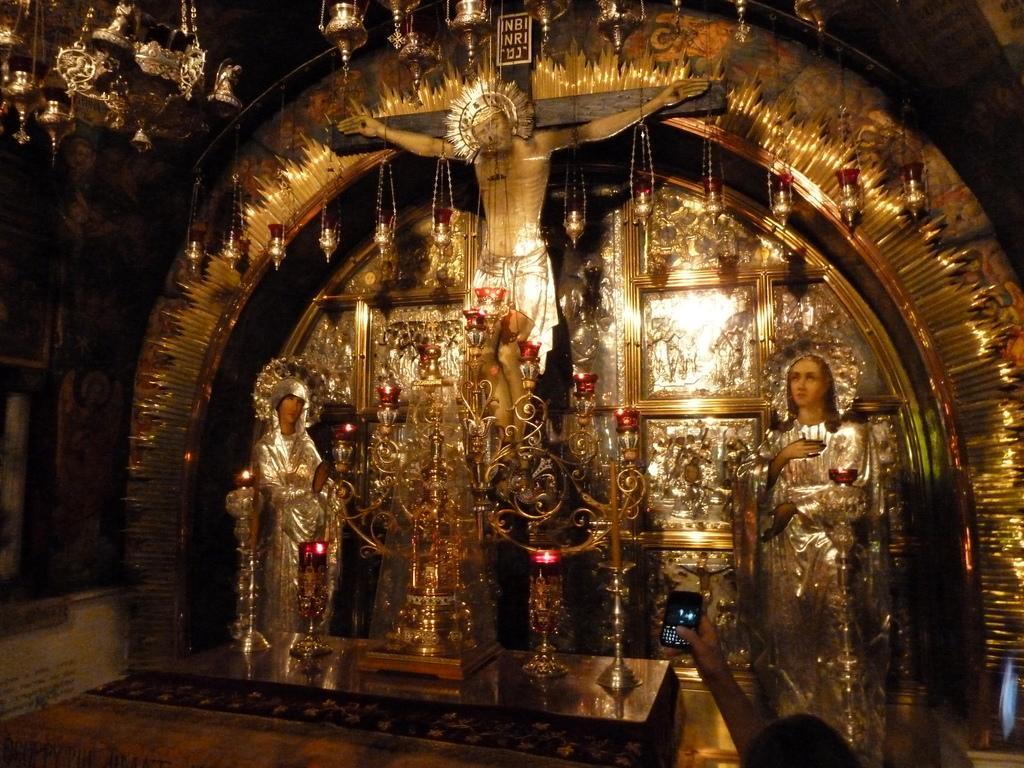Please provide a concise description of this image. In this picture we can see statues, name board, oil lamps, some objects and a person's hand is holding a mobile. 